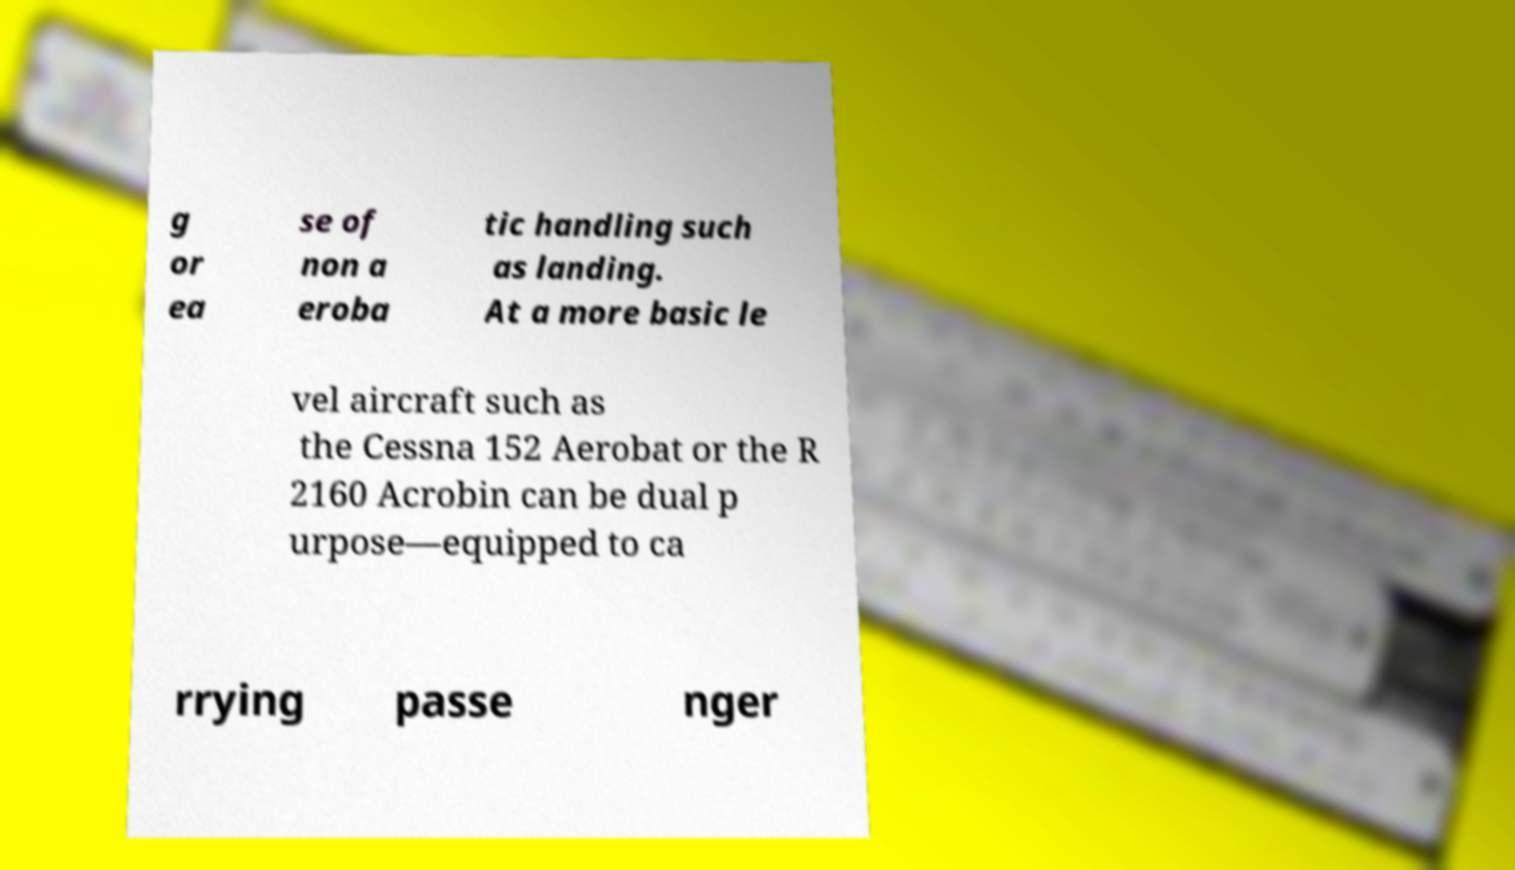What messages or text are displayed in this image? I need them in a readable, typed format. g or ea se of non a eroba tic handling such as landing. At a more basic le vel aircraft such as the Cessna 152 Aerobat or the R 2160 Acrobin can be dual p urpose—equipped to ca rrying passe nger 